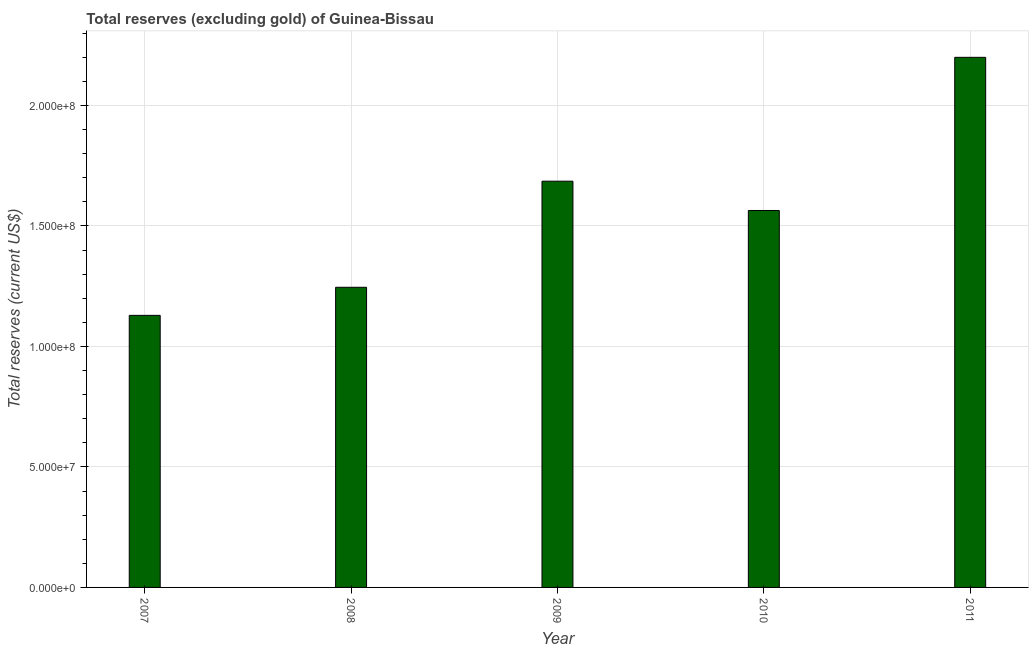What is the title of the graph?
Ensure brevity in your answer.  Total reserves (excluding gold) of Guinea-Bissau. What is the label or title of the Y-axis?
Give a very brief answer. Total reserves (current US$). What is the total reserves (excluding gold) in 2008?
Your answer should be very brief. 1.25e+08. Across all years, what is the maximum total reserves (excluding gold)?
Provide a succinct answer. 2.20e+08. Across all years, what is the minimum total reserves (excluding gold)?
Your answer should be compact. 1.13e+08. In which year was the total reserves (excluding gold) minimum?
Ensure brevity in your answer.  2007. What is the sum of the total reserves (excluding gold)?
Keep it short and to the point. 7.82e+08. What is the difference between the total reserves (excluding gold) in 2007 and 2008?
Provide a succinct answer. -1.17e+07. What is the average total reserves (excluding gold) per year?
Your response must be concise. 1.56e+08. What is the median total reserves (excluding gold)?
Your answer should be very brief. 1.56e+08. In how many years, is the total reserves (excluding gold) greater than 200000000 US$?
Offer a terse response. 1. What is the ratio of the total reserves (excluding gold) in 2008 to that in 2011?
Provide a short and direct response. 0.57. Is the total reserves (excluding gold) in 2008 less than that in 2009?
Your response must be concise. Yes. Is the difference between the total reserves (excluding gold) in 2008 and 2010 greater than the difference between any two years?
Offer a very short reply. No. What is the difference between the highest and the second highest total reserves (excluding gold)?
Provide a short and direct response. 5.14e+07. Is the sum of the total reserves (excluding gold) in 2007 and 2009 greater than the maximum total reserves (excluding gold) across all years?
Offer a very short reply. Yes. What is the difference between the highest and the lowest total reserves (excluding gold)?
Your response must be concise. 1.07e+08. In how many years, is the total reserves (excluding gold) greater than the average total reserves (excluding gold) taken over all years?
Offer a very short reply. 2. How many bars are there?
Your answer should be compact. 5. Are all the bars in the graph horizontal?
Make the answer very short. No. What is the difference between two consecutive major ticks on the Y-axis?
Provide a short and direct response. 5.00e+07. What is the Total reserves (current US$) of 2007?
Ensure brevity in your answer.  1.13e+08. What is the Total reserves (current US$) in 2008?
Ensure brevity in your answer.  1.25e+08. What is the Total reserves (current US$) of 2009?
Offer a very short reply. 1.69e+08. What is the Total reserves (current US$) of 2010?
Make the answer very short. 1.56e+08. What is the Total reserves (current US$) of 2011?
Provide a short and direct response. 2.20e+08. What is the difference between the Total reserves (current US$) in 2007 and 2008?
Your answer should be compact. -1.17e+07. What is the difference between the Total reserves (current US$) in 2007 and 2009?
Ensure brevity in your answer.  -5.57e+07. What is the difference between the Total reserves (current US$) in 2007 and 2010?
Your answer should be compact. -4.35e+07. What is the difference between the Total reserves (current US$) in 2007 and 2011?
Offer a very short reply. -1.07e+08. What is the difference between the Total reserves (current US$) in 2008 and 2009?
Your response must be concise. -4.40e+07. What is the difference between the Total reserves (current US$) in 2008 and 2010?
Make the answer very short. -3.19e+07. What is the difference between the Total reserves (current US$) in 2008 and 2011?
Keep it short and to the point. -9.54e+07. What is the difference between the Total reserves (current US$) in 2009 and 2010?
Make the answer very short. 1.22e+07. What is the difference between the Total reserves (current US$) in 2009 and 2011?
Provide a succinct answer. -5.14e+07. What is the difference between the Total reserves (current US$) in 2010 and 2011?
Your response must be concise. -6.36e+07. What is the ratio of the Total reserves (current US$) in 2007 to that in 2008?
Give a very brief answer. 0.91. What is the ratio of the Total reserves (current US$) in 2007 to that in 2009?
Keep it short and to the point. 0.67. What is the ratio of the Total reserves (current US$) in 2007 to that in 2010?
Your answer should be compact. 0.72. What is the ratio of the Total reserves (current US$) in 2007 to that in 2011?
Your answer should be compact. 0.51. What is the ratio of the Total reserves (current US$) in 2008 to that in 2009?
Give a very brief answer. 0.74. What is the ratio of the Total reserves (current US$) in 2008 to that in 2010?
Offer a terse response. 0.8. What is the ratio of the Total reserves (current US$) in 2008 to that in 2011?
Offer a terse response. 0.57. What is the ratio of the Total reserves (current US$) in 2009 to that in 2010?
Provide a short and direct response. 1.08. What is the ratio of the Total reserves (current US$) in 2009 to that in 2011?
Offer a very short reply. 0.77. What is the ratio of the Total reserves (current US$) in 2010 to that in 2011?
Ensure brevity in your answer.  0.71. 